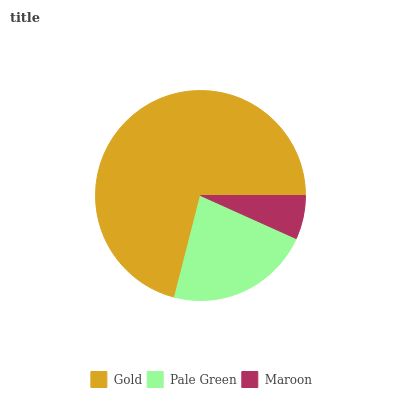Is Maroon the minimum?
Answer yes or no. Yes. Is Gold the maximum?
Answer yes or no. Yes. Is Pale Green the minimum?
Answer yes or no. No. Is Pale Green the maximum?
Answer yes or no. No. Is Gold greater than Pale Green?
Answer yes or no. Yes. Is Pale Green less than Gold?
Answer yes or no. Yes. Is Pale Green greater than Gold?
Answer yes or no. No. Is Gold less than Pale Green?
Answer yes or no. No. Is Pale Green the high median?
Answer yes or no. Yes. Is Pale Green the low median?
Answer yes or no. Yes. Is Gold the high median?
Answer yes or no. No. Is Gold the low median?
Answer yes or no. No. 